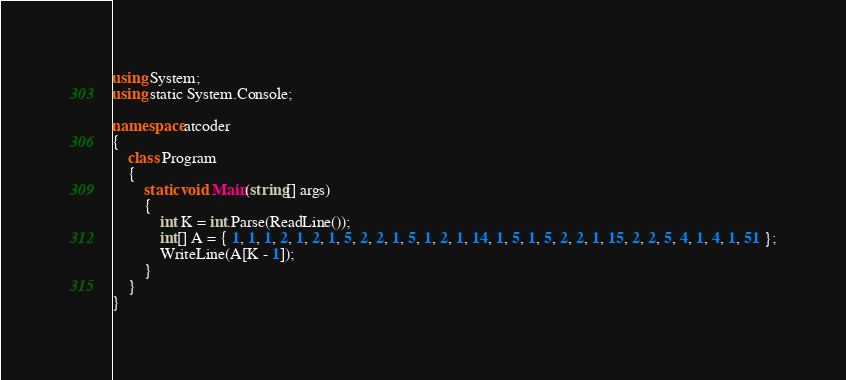Convert code to text. <code><loc_0><loc_0><loc_500><loc_500><_C#_>using System;
using static System.Console;

namespace atcoder
{
    class Program
    {
        static void Main(string[] args)
        {
            int K = int.Parse(ReadLine());
            int[] A = { 1, 1, 1, 2, 1, 2, 1, 5, 2, 2, 1, 5, 1, 2, 1, 14, 1, 5, 1, 5, 2, 2, 1, 15, 2, 2, 5, 4, 1, 4, 1, 51 };
            WriteLine(A[K - 1]);
        }
    }
}</code> 